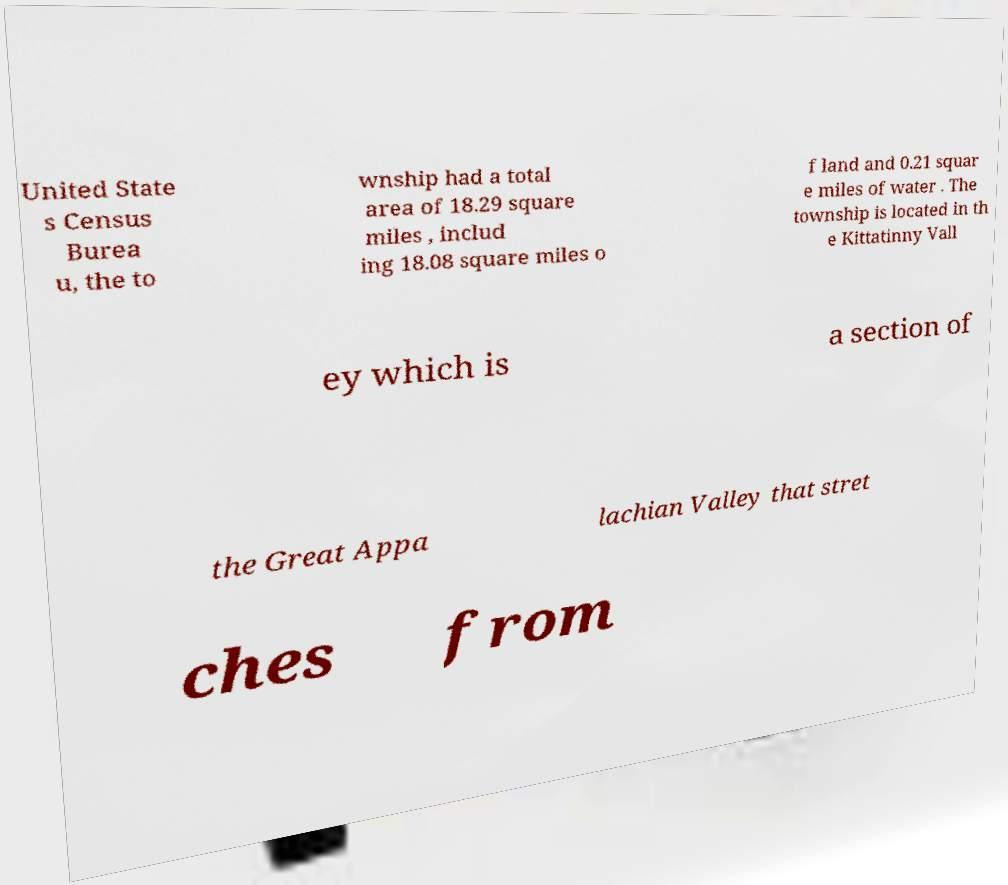Please identify and transcribe the text found in this image. United State s Census Burea u, the to wnship had a total area of 18.29 square miles , includ ing 18.08 square miles o f land and 0.21 squar e miles of water . The township is located in th e Kittatinny Vall ey which is a section of the Great Appa lachian Valley that stret ches from 